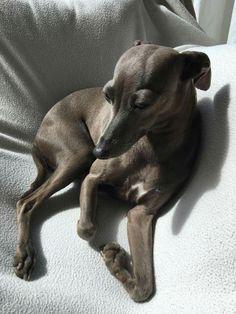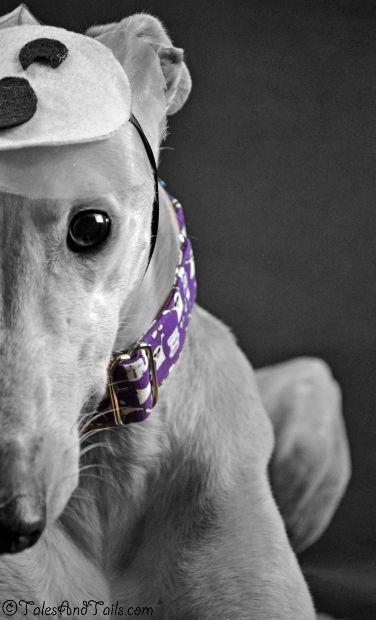The first image is the image on the left, the second image is the image on the right. For the images shown, is this caption "One image shows one brown dog reclining, and the other image features a hound wearing a collar." true? Answer yes or no. Yes. The first image is the image on the left, the second image is the image on the right. Assess this claim about the two images: "There is three dogs.". Correct or not? Answer yes or no. No. 